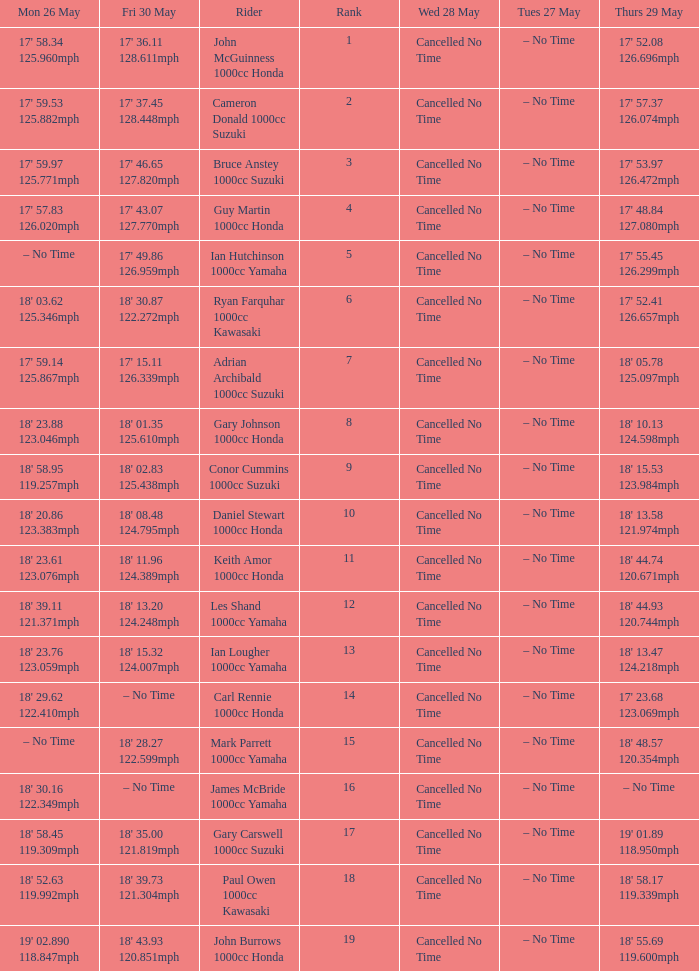What tims is wed may 28 and mon may 26 is 17' 58.34 125.960mph? Cancelled No Time. 